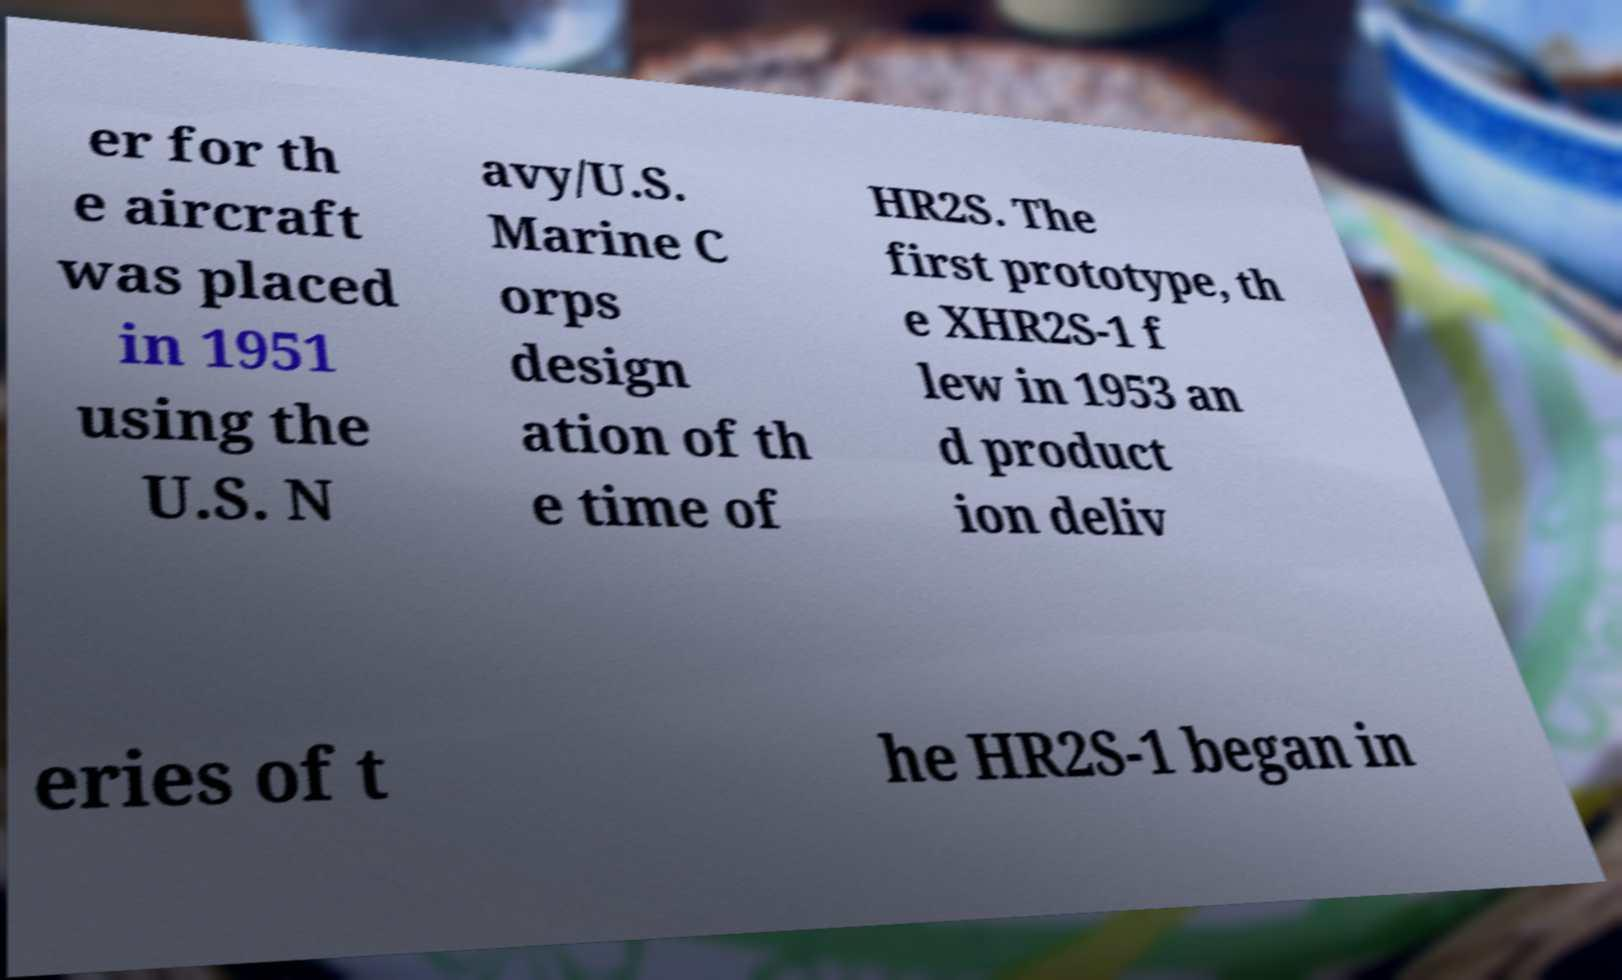Please read and relay the text visible in this image. What does it say? er for th e aircraft was placed in 1951 using the U.S. N avy/U.S. Marine C orps design ation of th e time of HR2S. The first prototype, th e XHR2S-1 f lew in 1953 an d product ion deliv eries of t he HR2S-1 began in 